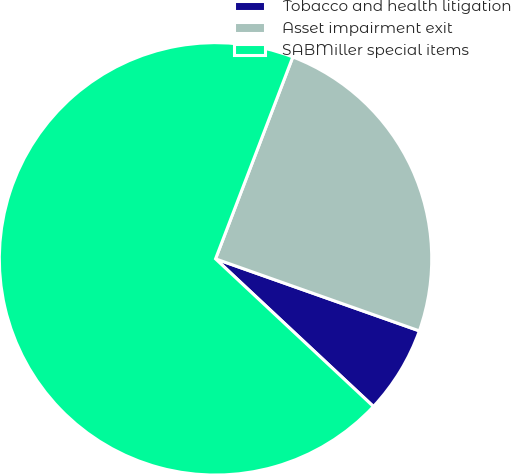<chart> <loc_0><loc_0><loc_500><loc_500><pie_chart><fcel>Tobacco and health litigation<fcel>Asset impairment exit<fcel>SABMiller special items<nl><fcel>6.56%<fcel>24.59%<fcel>68.85%<nl></chart> 